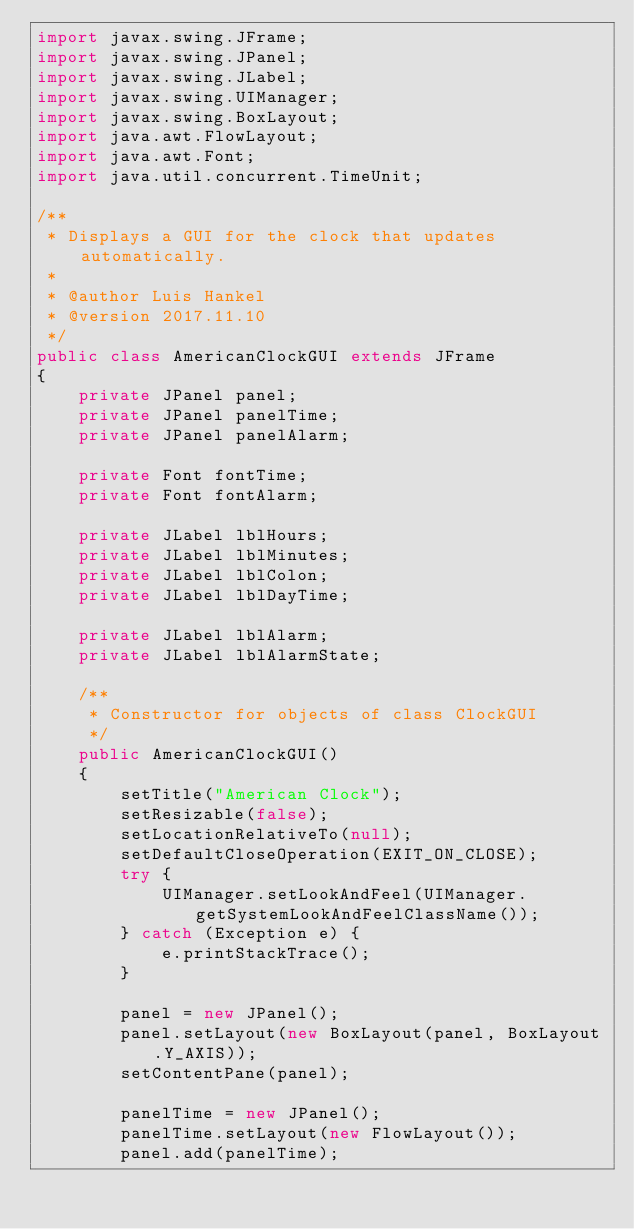Convert code to text. <code><loc_0><loc_0><loc_500><loc_500><_Java_>import javax.swing.JFrame;
import javax.swing.JPanel;
import javax.swing.JLabel;
import javax.swing.UIManager;
import javax.swing.BoxLayout;
import java.awt.FlowLayout;
import java.awt.Font;
import java.util.concurrent.TimeUnit;

/**
 * Displays a GUI for the clock that updates automatically.
 *
 * @author Luis Hankel
 * @version 2017.11.10
 */
public class AmericanClockGUI extends JFrame
{
    private JPanel panel;
    private JPanel panelTime;
    private JPanel panelAlarm;
    
    private Font fontTime;
    private Font fontAlarm;
    
    private JLabel lblHours;
    private JLabel lblMinutes;
    private JLabel lblColon;
    private JLabel lblDayTime;
    
    private JLabel lblAlarm;
    private JLabel lblAlarmState;

    /**
     * Constructor for objects of class ClockGUI
     */
    public AmericanClockGUI()
    {
        setTitle("American Clock");
        setResizable(false);
        setLocationRelativeTo(null);
        setDefaultCloseOperation(EXIT_ON_CLOSE);
        try {
            UIManager.setLookAndFeel(UIManager.getSystemLookAndFeelClassName());
        } catch (Exception e) {
            e.printStackTrace();
        }
        
        panel = new JPanel();
        panel.setLayout(new BoxLayout(panel, BoxLayout.Y_AXIS));
        setContentPane(panel);
        
        panelTime = new JPanel();
        panelTime.setLayout(new FlowLayout());
        panel.add(panelTime);
        </code> 